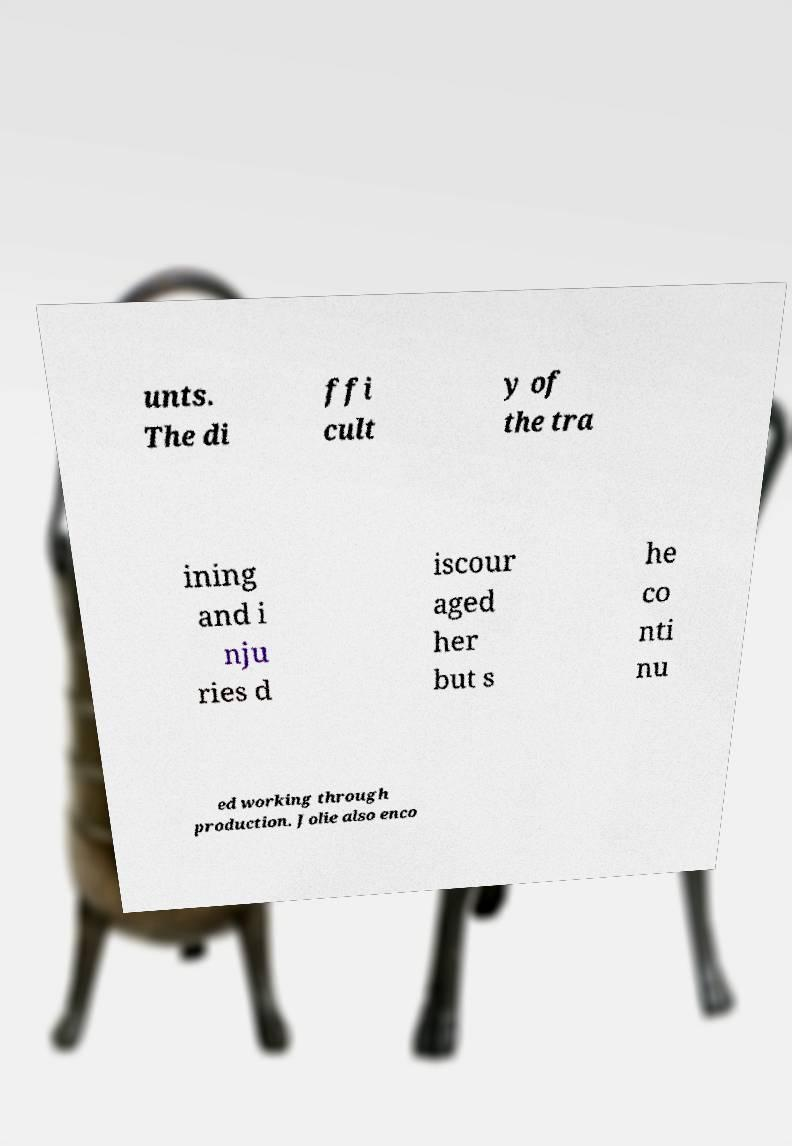There's text embedded in this image that I need extracted. Can you transcribe it verbatim? unts. The di ffi cult y of the tra ining and i nju ries d iscour aged her but s he co nti nu ed working through production. Jolie also enco 